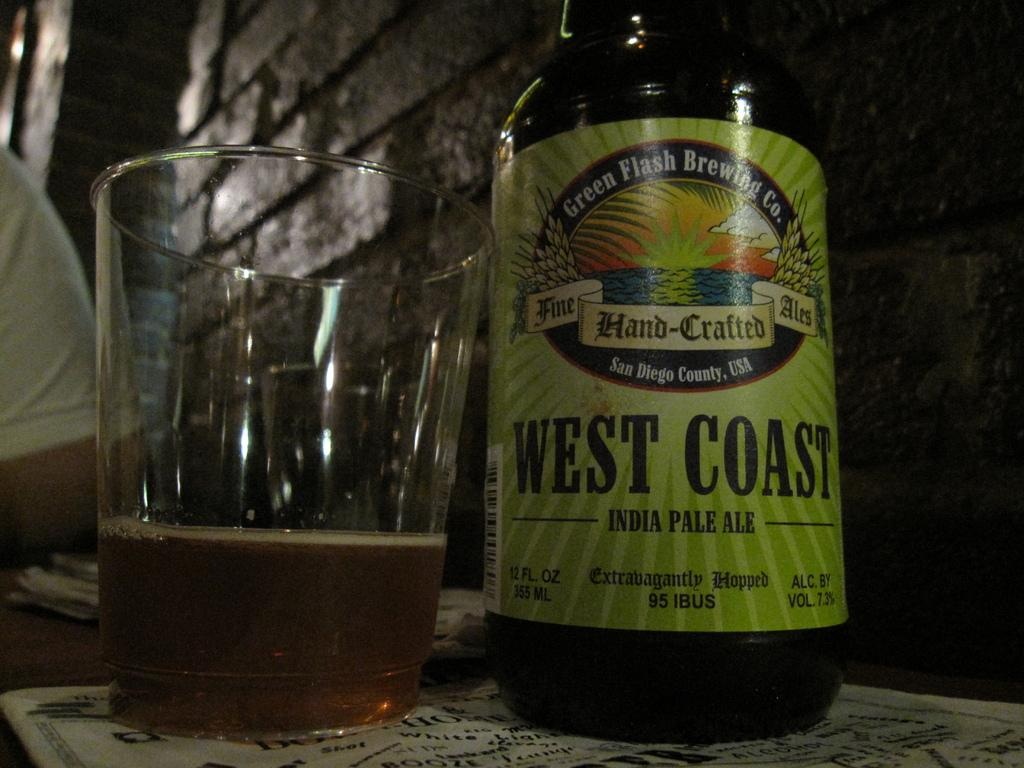Provide a one-sentence caption for the provided image. a bottle of beer with west coast on it. 